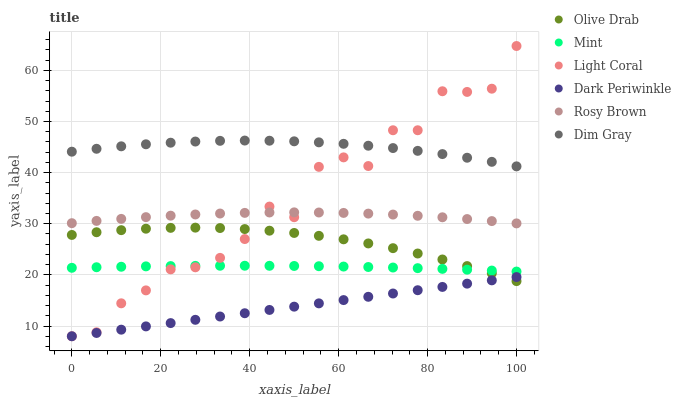Does Dark Periwinkle have the minimum area under the curve?
Answer yes or no. Yes. Does Dim Gray have the maximum area under the curve?
Answer yes or no. Yes. Does Rosy Brown have the minimum area under the curve?
Answer yes or no. No. Does Rosy Brown have the maximum area under the curve?
Answer yes or no. No. Is Dark Periwinkle the smoothest?
Answer yes or no. Yes. Is Light Coral the roughest?
Answer yes or no. Yes. Is Rosy Brown the smoothest?
Answer yes or no. No. Is Rosy Brown the roughest?
Answer yes or no. No. Does Light Coral have the lowest value?
Answer yes or no. Yes. Does Rosy Brown have the lowest value?
Answer yes or no. No. Does Light Coral have the highest value?
Answer yes or no. Yes. Does Rosy Brown have the highest value?
Answer yes or no. No. Is Dark Periwinkle less than Rosy Brown?
Answer yes or no. Yes. Is Rosy Brown greater than Dark Periwinkle?
Answer yes or no. Yes. Does Light Coral intersect Dim Gray?
Answer yes or no. Yes. Is Light Coral less than Dim Gray?
Answer yes or no. No. Is Light Coral greater than Dim Gray?
Answer yes or no. No. Does Dark Periwinkle intersect Rosy Brown?
Answer yes or no. No. 